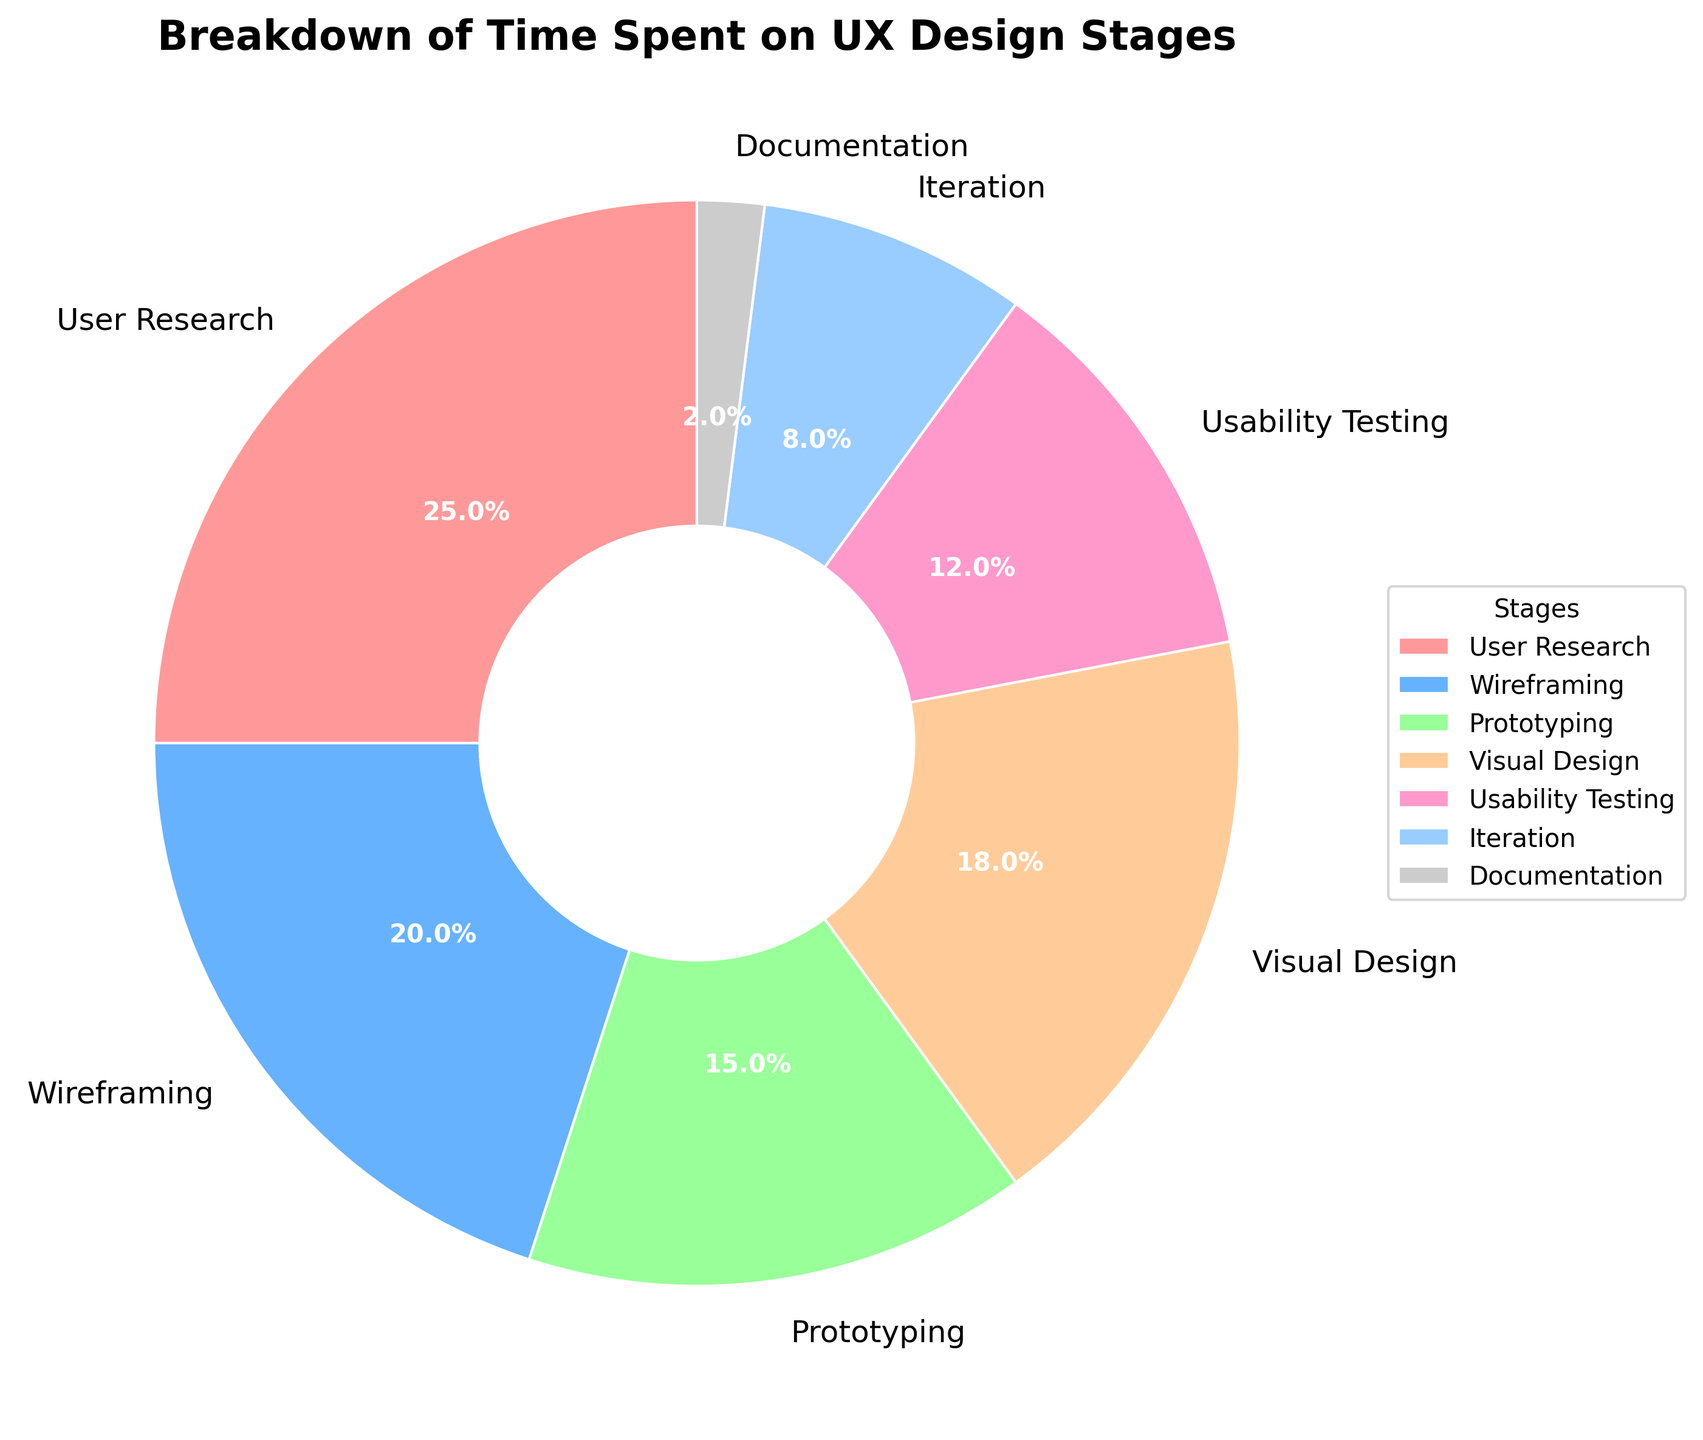What percentage of time is spent on User Research? The pie chart shows the breakdown of time spent on different stages of the UX design process. Locate User Research and read the percentage value next to it.
Answer: 25% Which stage has the smallest percentage of time spent? Examine the pie chart and identify the segment with the smallest percentage value.
Answer: Documentation How much more time is spent on Wireframing compared to Iteration? Find the percentages for both Wireframing and Iteration from the chart and subtract the smaller value from the larger value (20% - 8%).
Answer: 12% What is the total percentage of time spent on Prototyping and Usability Testing combined? Add the percentages of Prototyping and Usability Testing (15% + 12%).
Answer: 27% Which stage has a higher percentage of time allocated, Visual Design or User Research? Compare the percentage values for Visual Design and User Research from the chart (Visual Design: 18%, User Research: 25%).
Answer: User Research How does the time spent on Iteration compare to that on Documentation? Look at the chart and compare the percentage values for Iteration and Documentation (Iteration: 8%, Documentation: 2%).
Answer: Iteration is 6% more What is the difference in time spent between the stage with the highest percentage and the stage with the lowest percentage? Identify the stages with the highest and lowest percentages; then, subtract the smallest percentage from the largest percentage (25% - 2%).
Answer: 23% If the total time available is 100 hours, how many hours are spent on Visual Design? The total hours is 100, so to find the hours spent on Visual Design, multiply 100 by 18% (100 * 0.18).
Answer: 18 hours What percentage of time is spent on stages other than User Research and Wireframing? Find the sum of the percentages for User Research and Wireframing and subtract that from the total percentage (100% - (25% + 20%)).
Answer: 55% Which color is used to represent Usability Testing? Identify the segment labeled "Usability Testing" and note the color used for this segment from the chart.
Answer: Pink 